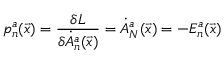Convert formula to latex. <formula><loc_0><loc_0><loc_500><loc_500>p _ { n } ^ { a } ( \vec { x } ) = { \frac { \delta L } { \delta \dot { A } _ { n } ^ { a } ( \vec { x } ) } } = \dot { A } _ { N } ^ { a } ( \vec { x } ) = - E _ { n } ^ { a } ( \vec { x } )</formula> 